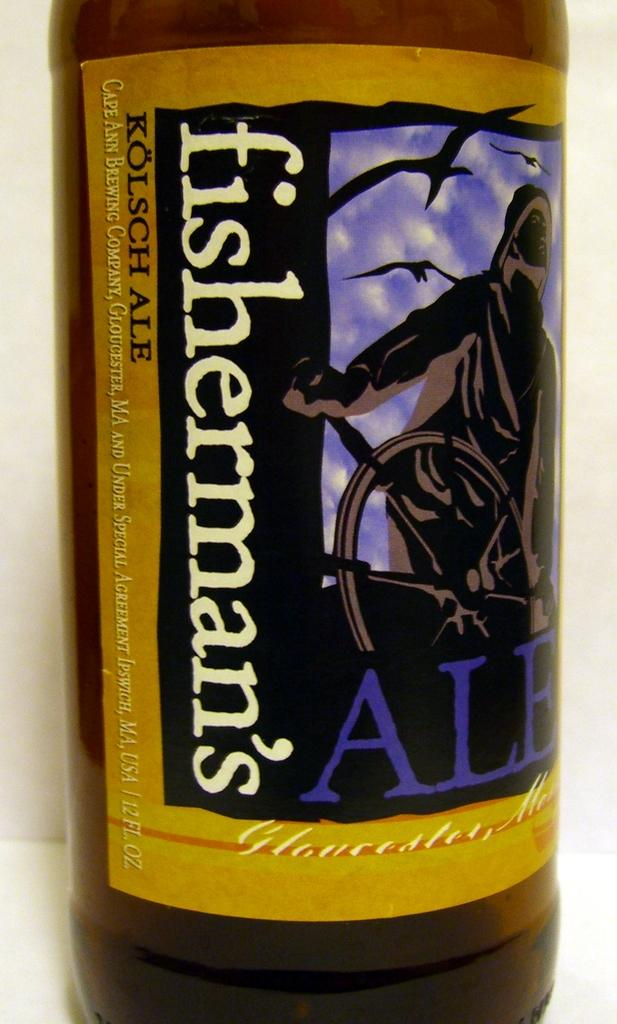<image>
Give a short and clear explanation of the subsequent image. a close up of a bottle of Fisherman's ale 